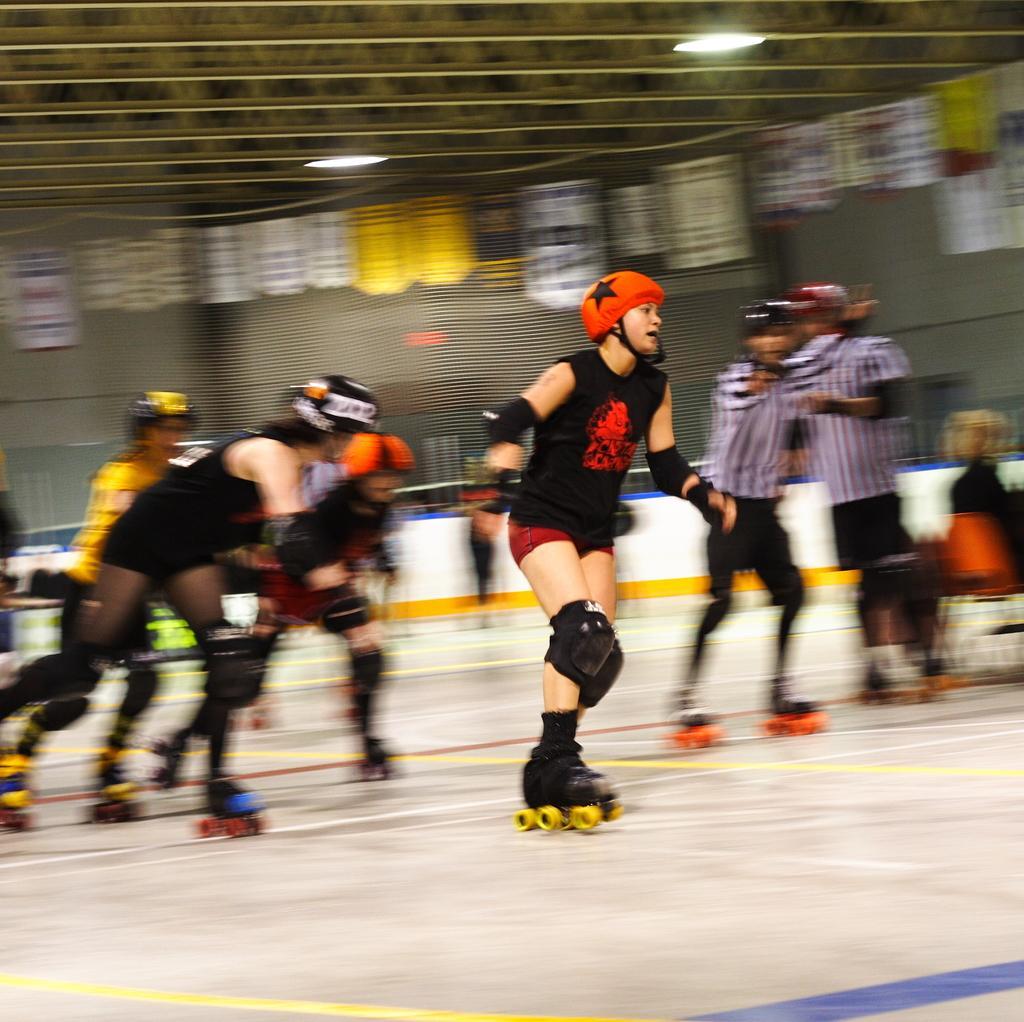Could you give a brief overview of what you see in this image? In this picture, we see people are skating. Behind them, we see a white wall. In the background, we see a grey wall and at the top, we see the posters or the banners in white and yellow color. At the top, we see the ceiling. This picture might be clicked in the indoor stadium. 